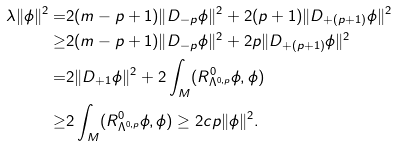Convert formula to latex. <formula><loc_0><loc_0><loc_500><loc_500>\lambda \| \phi \| ^ { 2 } = & 2 ( m - p + 1 ) \| D _ { - p } \phi \| ^ { 2 } + 2 ( p + 1 ) \| D _ { + ( p + 1 ) } \phi \| ^ { 2 } \\ \geq & 2 ( m - p + 1 ) \| D _ { - p } \phi \| ^ { 2 } + 2 p \| D _ { + ( p + 1 ) } \phi \| ^ { 2 } \\ = & 2 \| D _ { + 1 } \phi \| ^ { 2 } + 2 \int _ { M } ( R _ { \Lambda ^ { 0 , p } } ^ { 0 } \phi , \phi ) \\ \geq & 2 \int _ { M } ( R _ { \Lambda ^ { 0 , p } } ^ { 0 } \phi , \phi ) \geq 2 c p \| \phi \| ^ { 2 } .</formula> 